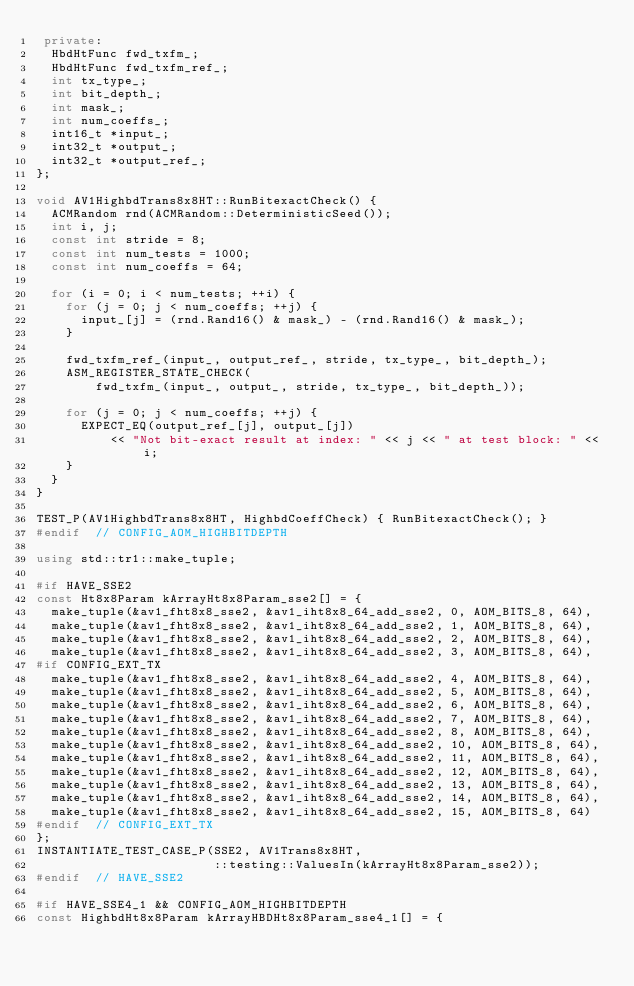Convert code to text. <code><loc_0><loc_0><loc_500><loc_500><_C++_> private:
  HbdHtFunc fwd_txfm_;
  HbdHtFunc fwd_txfm_ref_;
  int tx_type_;
  int bit_depth_;
  int mask_;
  int num_coeffs_;
  int16_t *input_;
  int32_t *output_;
  int32_t *output_ref_;
};

void AV1HighbdTrans8x8HT::RunBitexactCheck() {
  ACMRandom rnd(ACMRandom::DeterministicSeed());
  int i, j;
  const int stride = 8;
  const int num_tests = 1000;
  const int num_coeffs = 64;

  for (i = 0; i < num_tests; ++i) {
    for (j = 0; j < num_coeffs; ++j) {
      input_[j] = (rnd.Rand16() & mask_) - (rnd.Rand16() & mask_);
    }

    fwd_txfm_ref_(input_, output_ref_, stride, tx_type_, bit_depth_);
    ASM_REGISTER_STATE_CHECK(
        fwd_txfm_(input_, output_, stride, tx_type_, bit_depth_));

    for (j = 0; j < num_coeffs; ++j) {
      EXPECT_EQ(output_ref_[j], output_[j])
          << "Not bit-exact result at index: " << j << " at test block: " << i;
    }
  }
}

TEST_P(AV1HighbdTrans8x8HT, HighbdCoeffCheck) { RunBitexactCheck(); }
#endif  // CONFIG_AOM_HIGHBITDEPTH

using std::tr1::make_tuple;

#if HAVE_SSE2
const Ht8x8Param kArrayHt8x8Param_sse2[] = {
  make_tuple(&av1_fht8x8_sse2, &av1_iht8x8_64_add_sse2, 0, AOM_BITS_8, 64),
  make_tuple(&av1_fht8x8_sse2, &av1_iht8x8_64_add_sse2, 1, AOM_BITS_8, 64),
  make_tuple(&av1_fht8x8_sse2, &av1_iht8x8_64_add_sse2, 2, AOM_BITS_8, 64),
  make_tuple(&av1_fht8x8_sse2, &av1_iht8x8_64_add_sse2, 3, AOM_BITS_8, 64),
#if CONFIG_EXT_TX
  make_tuple(&av1_fht8x8_sse2, &av1_iht8x8_64_add_sse2, 4, AOM_BITS_8, 64),
  make_tuple(&av1_fht8x8_sse2, &av1_iht8x8_64_add_sse2, 5, AOM_BITS_8, 64),
  make_tuple(&av1_fht8x8_sse2, &av1_iht8x8_64_add_sse2, 6, AOM_BITS_8, 64),
  make_tuple(&av1_fht8x8_sse2, &av1_iht8x8_64_add_sse2, 7, AOM_BITS_8, 64),
  make_tuple(&av1_fht8x8_sse2, &av1_iht8x8_64_add_sse2, 8, AOM_BITS_8, 64),
  make_tuple(&av1_fht8x8_sse2, &av1_iht8x8_64_add_sse2, 10, AOM_BITS_8, 64),
  make_tuple(&av1_fht8x8_sse2, &av1_iht8x8_64_add_sse2, 11, AOM_BITS_8, 64),
  make_tuple(&av1_fht8x8_sse2, &av1_iht8x8_64_add_sse2, 12, AOM_BITS_8, 64),
  make_tuple(&av1_fht8x8_sse2, &av1_iht8x8_64_add_sse2, 13, AOM_BITS_8, 64),
  make_tuple(&av1_fht8x8_sse2, &av1_iht8x8_64_add_sse2, 14, AOM_BITS_8, 64),
  make_tuple(&av1_fht8x8_sse2, &av1_iht8x8_64_add_sse2, 15, AOM_BITS_8, 64)
#endif  // CONFIG_EXT_TX
};
INSTANTIATE_TEST_CASE_P(SSE2, AV1Trans8x8HT,
                        ::testing::ValuesIn(kArrayHt8x8Param_sse2));
#endif  // HAVE_SSE2

#if HAVE_SSE4_1 && CONFIG_AOM_HIGHBITDEPTH
const HighbdHt8x8Param kArrayHBDHt8x8Param_sse4_1[] = {</code> 